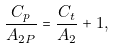Convert formula to latex. <formula><loc_0><loc_0><loc_500><loc_500>\frac { C _ { p } } { A _ { 2 P } } = \frac { C _ { t } } { A _ { 2 } } + 1 ,</formula> 